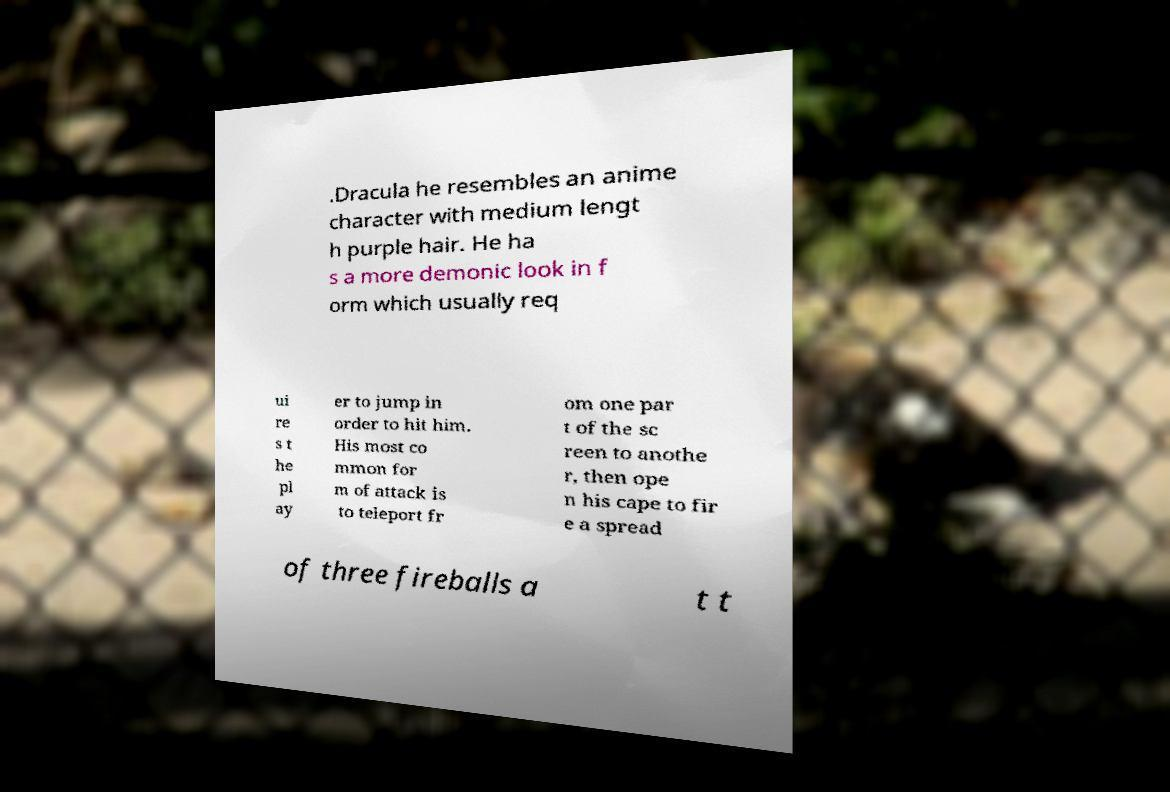Please identify and transcribe the text found in this image. .Dracula he resembles an anime character with medium lengt h purple hair. He ha s a more demonic look in f orm which usually req ui re s t he pl ay er to jump in order to hit him. His most co mmon for m of attack is to teleport fr om one par t of the sc reen to anothe r, then ope n his cape to fir e a spread of three fireballs a t t 